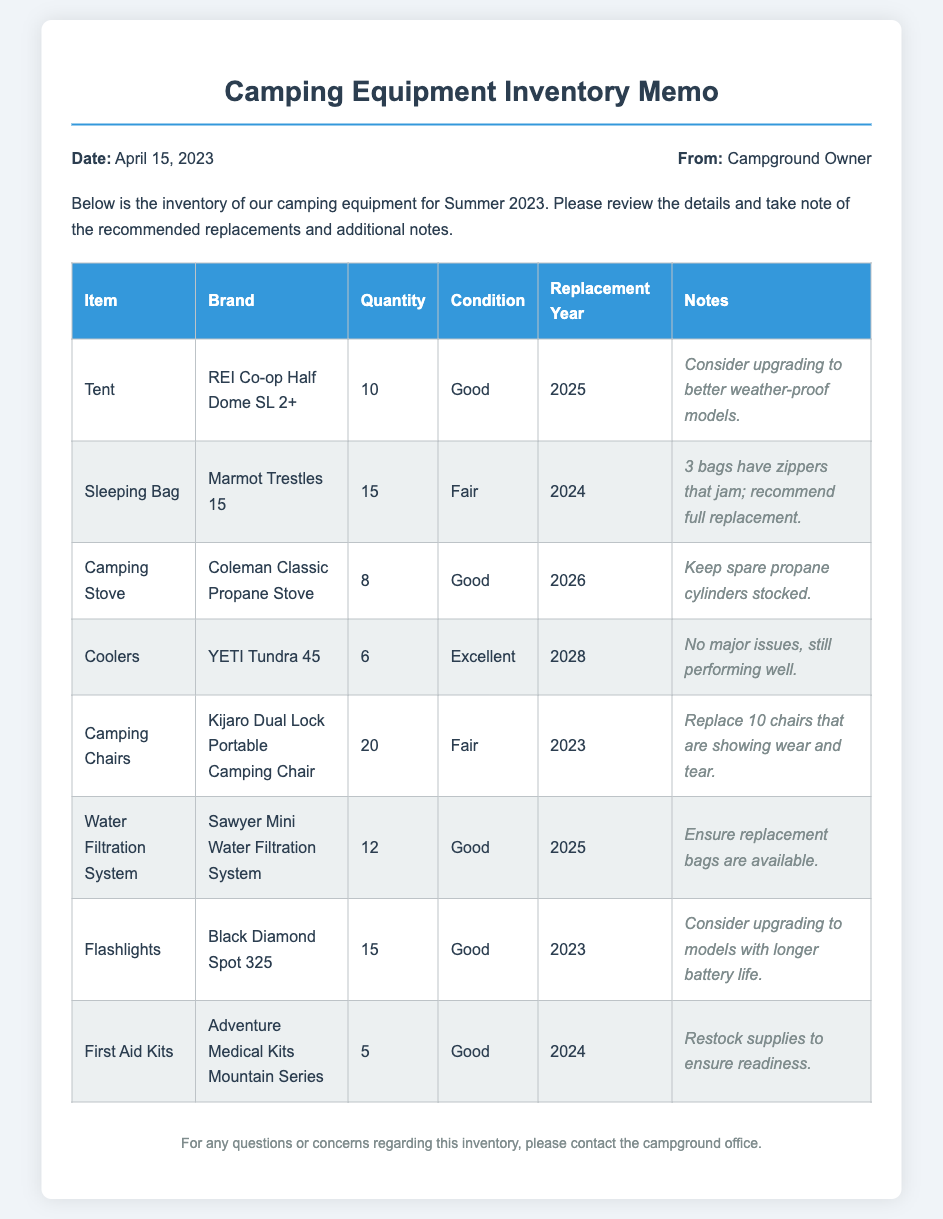what is the date of the memo? The date of the memo is stated at the top of the document as April 15, 2023.
Answer: April 15, 2023 how many camping stoves are in inventory? The inventory lists a total of 8 camping stoves available.
Answer: 8 what is the condition of the first aid kits? The document states that the first aid kits are in good condition.
Answer: Good which item has the earliest recommended replacement year? The camping chairs have the recommended replacement year of 2023, which is the earliest among the items.
Answer: 2023 how many tent units are scheduled for replacement in 2025? The inventory indicates there are 10 tents scheduled for replacement in 2025.
Answer: 10 what brand is recommended for the water filtration system? The memo specifies Sawyer Mini Water Filtration System as the brand for the water filtration system.
Answer: Sawyer Mini Water Filtration System how many camping chairs should be replaced? The document notes that 10 camping chairs are showing wear and tear and should be replaced.
Answer: 10 which camping equipment is noted for needing spare accessories? The camping stove is mentioned as needing spare propane cylinders stocked.
Answer: Camping Stove what is the total quantity of sleeping bags listed? The inventory mentions a total of 15 sleeping bags.
Answer: 15 